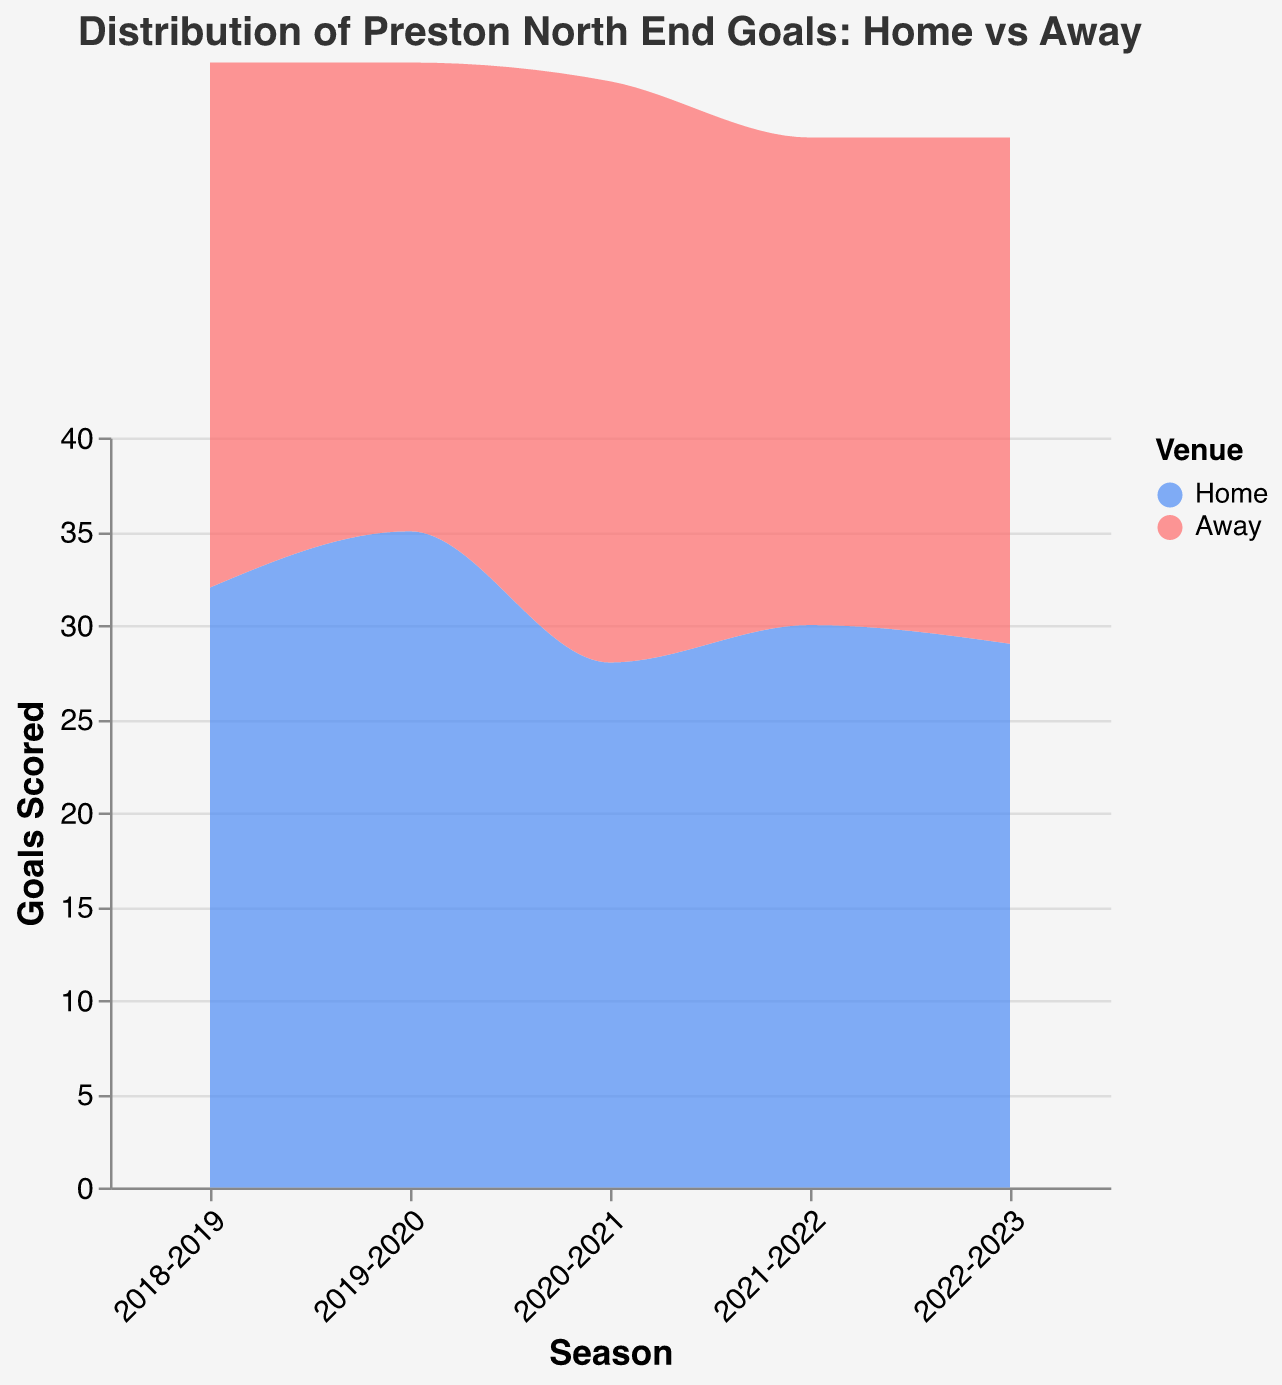What's the distribution title? The title is usually displayed at the top of the figure.
Answer: Distribution of Preston North End Goals: Home vs Away What are the two types of venues shown? Look at the legend on the figure, which defines the different categories by color.
Answer: Home and Away Which season had the highest number of goals scored at home? The highest point on the "Home" area plot represents the season with the highest goals.
Answer: 2019-2020 How many goals did Preston North End score at home in the 2020-2021 season? Find the data point on the "Home" line for the 2020-2021 season.
Answer: 28 In which season did Preston North End score more goals away than at home? Compare the "Home" and "Away" areas for each season to find where the "Away" is higher.
Answer: 2020-2021 What is the goal difference between home and away in the 2019-2020 season? Subtract the number of away goals from the number of home goals for that specific season.
Answer: 10 (35 - 25) Which season saw an equal number of home and away goals? Look for overlapping areas of the same height for "Home" and "Away".
Answer: None What's the average number of goals scored at home across the five seasons? Add the home goals for each season and divide by the number of seasons: \((32 + 35 + 28 + 30 + 29) / 5\).
Answer: 30.8 Compare the total goals scored at home to those scored away over the five seasons. Which is higher? Sum the goals for each venue over the five seasons and compare the totals: Total Home = \((32 + 35 + 28 + 30 + 29) = 154\); Total Away = \((28 + 25 + 31 + 26 + 27) = 137\).
Answer: Home is higher by 17 goals What is the range of goals scored at home across the five seasons? Find the difference between the highest and lowest goals scored at home from the data.
Answer: 7 (35 - 28) 